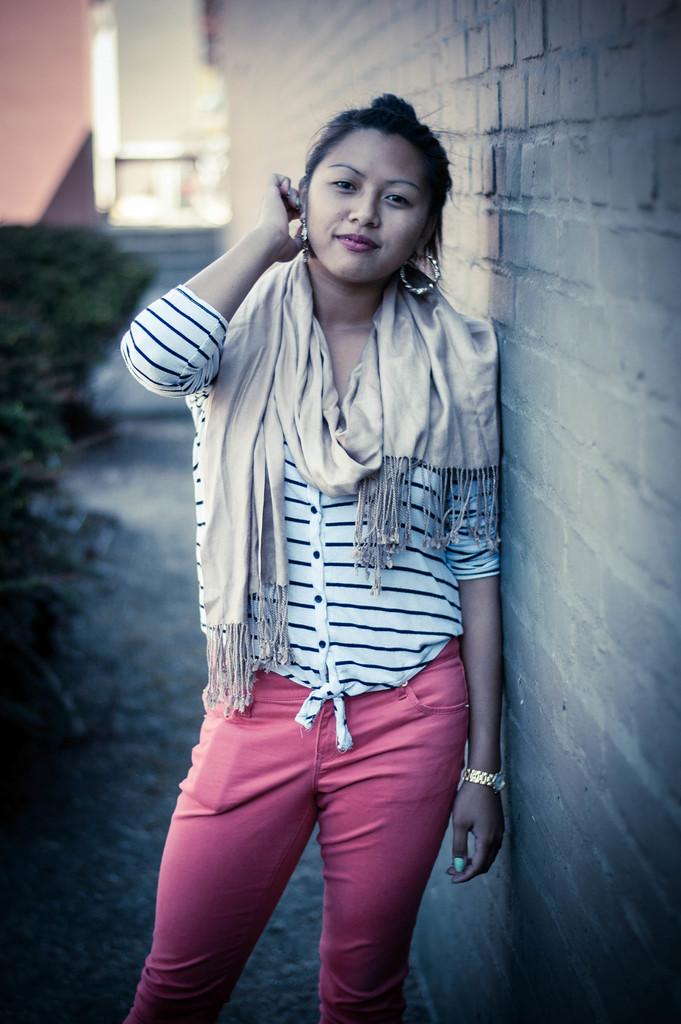What is the main subject in the image? There is a woman standing in the image. What can be seen behind the woman? There is a wall visible in the image. How would you describe the background of the image? The background of the image is blurred. How many crates are stacked on the woman's feet in the image? There are no crates present in the image, and the woman's feet are not visible. 